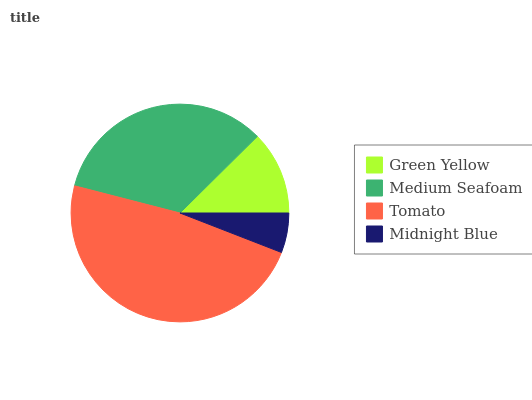Is Midnight Blue the minimum?
Answer yes or no. Yes. Is Tomato the maximum?
Answer yes or no. Yes. Is Medium Seafoam the minimum?
Answer yes or no. No. Is Medium Seafoam the maximum?
Answer yes or no. No. Is Medium Seafoam greater than Green Yellow?
Answer yes or no. Yes. Is Green Yellow less than Medium Seafoam?
Answer yes or no. Yes. Is Green Yellow greater than Medium Seafoam?
Answer yes or no. No. Is Medium Seafoam less than Green Yellow?
Answer yes or no. No. Is Medium Seafoam the high median?
Answer yes or no. Yes. Is Green Yellow the low median?
Answer yes or no. Yes. Is Green Yellow the high median?
Answer yes or no. No. Is Midnight Blue the low median?
Answer yes or no. No. 